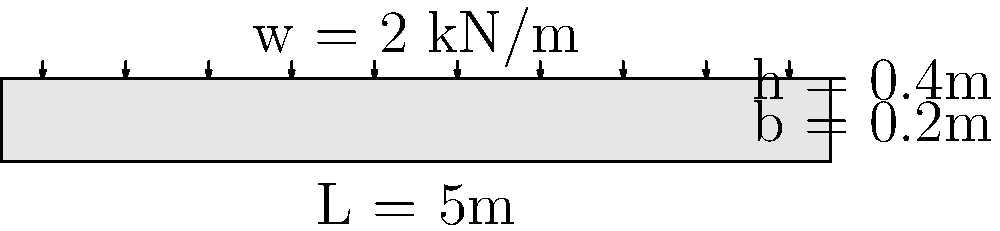As a retired engineer who has witnessed the evolution of structural design practices, consider a simply supported concrete beam with a span of 5 meters. The beam has a rectangular cross-section with a width of 0.2 meters and a height of 0.4 meters. It is subjected to a uniformly distributed load of 2 kN/m along its entire length. Given that the concrete has a characteristic compressive strength ($f_{ck}$) of 30 MPa and the allowable bending stress ($\sigma_{allow}$) is 10 MPa, calculate the maximum bending moment the beam can safely support. How does this compare to the actual bending moment under the given load? Let's approach this step-by-step:

1) First, calculate the moment of inertia (I) of the beam:
   $$I = \frac{bh^3}{12} = \frac{0.2 \times 0.4^3}{12} = 1.0667 \times 10^{-3} m^4$$

2) Calculate the section modulus (Z):
   $$Z = \frac{I}{y} = \frac{1.0667 \times 10^{-3}}{0.4/2} = 5.3333 \times 10^{-3} m^3$$

3) The maximum bending moment the beam can safely support is:
   $$M_{max} = \sigma_{allow} \times Z = 10 \times 10^6 \times 5.3333 \times 10^{-3} = 53,333 Nm = 53.333 kNm$$

4) Now, calculate the actual bending moment under the given load:
   For a simply supported beam with uniformly distributed load (w), the maximum bending moment occurs at the center and is given by:
   $$M_{actual} = \frac{wL^2}{8} = \frac{2 \times 5^2}{8} = 6.25 kNm$$

5) Compare the two moments:
   The maximum safe bending moment (53.333 kNm) is significantly higher than the actual bending moment (6.25 kNm) under the given load.
Answer: The beam can safely support a maximum bending moment of 53.333 kNm, which is about 8.5 times the actual bending moment of 6.25 kNm under the given load. 